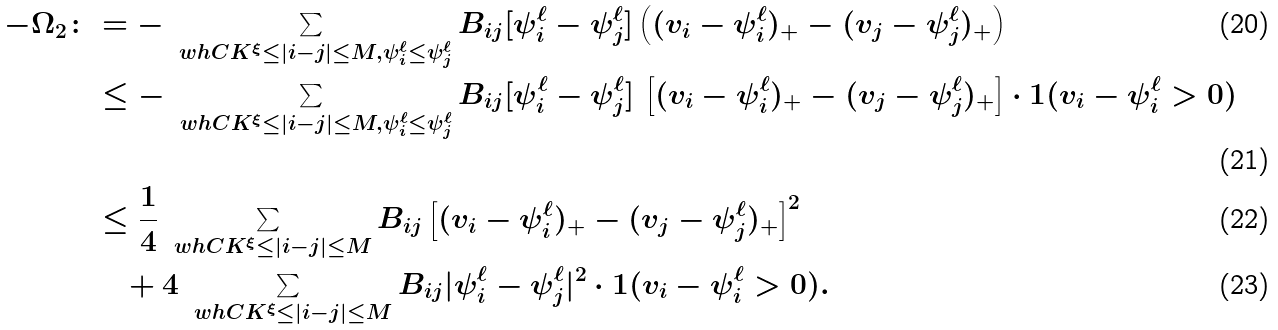Convert formula to latex. <formula><loc_0><loc_0><loc_500><loc_500>- \Omega _ { 2 } \colon & = - \sum _ { \ w h C K ^ { \xi } \leq | i - j | \leq M , \psi ^ { \ell } _ { i } \leq \psi ^ { \ell } _ { j } } B _ { i j } [ \psi ^ { \ell } _ { i } - \psi ^ { \ell } _ { j } ] \left ( ( v _ { i } - \psi ^ { \ell } _ { i } ) _ { + } - ( v _ { j } - \psi ^ { \ell } _ { j } ) _ { + } \right ) \\ & \leq - \sum _ { \ w h C K ^ { \xi } \leq | i - j | \leq M , \psi ^ { \ell } _ { i } \leq \psi ^ { \ell } _ { j } } B _ { i j } [ \psi ^ { \ell } _ { i } - \psi ^ { \ell } _ { j } ] \, \left [ ( v _ { i } - \psi ^ { \ell } _ { i } ) _ { + } - ( v _ { j } - \psi ^ { \ell } _ { j } ) _ { + } \right ] \cdot { 1 } ( v _ { i } - \psi ^ { \ell } _ { i } > 0 ) \\ & \leq \frac { 1 } { 4 } \sum _ { \ w h C K ^ { \xi } \leq | i - j | \leq M } B _ { i j } \left [ ( v _ { i } - \psi ^ { \ell } _ { i } ) _ { + } - ( v _ { j } - \psi ^ { \ell } _ { j } ) _ { + } \right ] ^ { 2 } \\ & \quad + 4 \sum _ { \ w h C K ^ { \xi } \leq | i - j | \leq M } B _ { i j } | \psi ^ { \ell } _ { i } - \psi ^ { \ell } _ { j } | ^ { 2 } \cdot { 1 } ( v _ { i } - \psi ^ { \ell } _ { i } > 0 ) .</formula> 